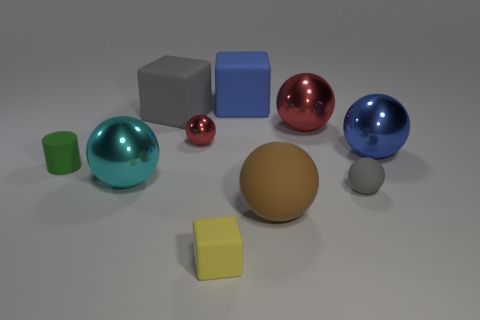Is there anything else that has the same material as the brown sphere?
Your answer should be very brief. Yes. Are there any other things that are the same shape as the cyan metallic object?
Give a very brief answer. Yes. What color is the large rubber thing that is the same shape as the large blue metallic object?
Your answer should be compact. Brown. Do the green matte thing and the gray ball have the same size?
Your response must be concise. Yes. What number of other things are there of the same size as the yellow rubber cube?
Offer a very short reply. 3. How many things are objects right of the brown matte object or big metallic objects in front of the tiny metal sphere?
Offer a very short reply. 4. There is a gray matte object that is the same size as the brown matte thing; what shape is it?
Keep it short and to the point. Cube. There is a blue sphere that is made of the same material as the large red sphere; what is its size?
Your response must be concise. Large. Is the tiny green matte object the same shape as the big red object?
Ensure brevity in your answer.  No. There is a rubber ball that is the same size as the cyan metal ball; what color is it?
Make the answer very short. Brown. 